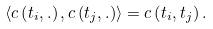Convert formula to latex. <formula><loc_0><loc_0><loc_500><loc_500>\left \langle c \left ( t _ { i } , . \right ) , c \left ( t _ { j } , . \right ) \right \rangle = c \left ( t _ { i } , t _ { j } \right ) .</formula> 